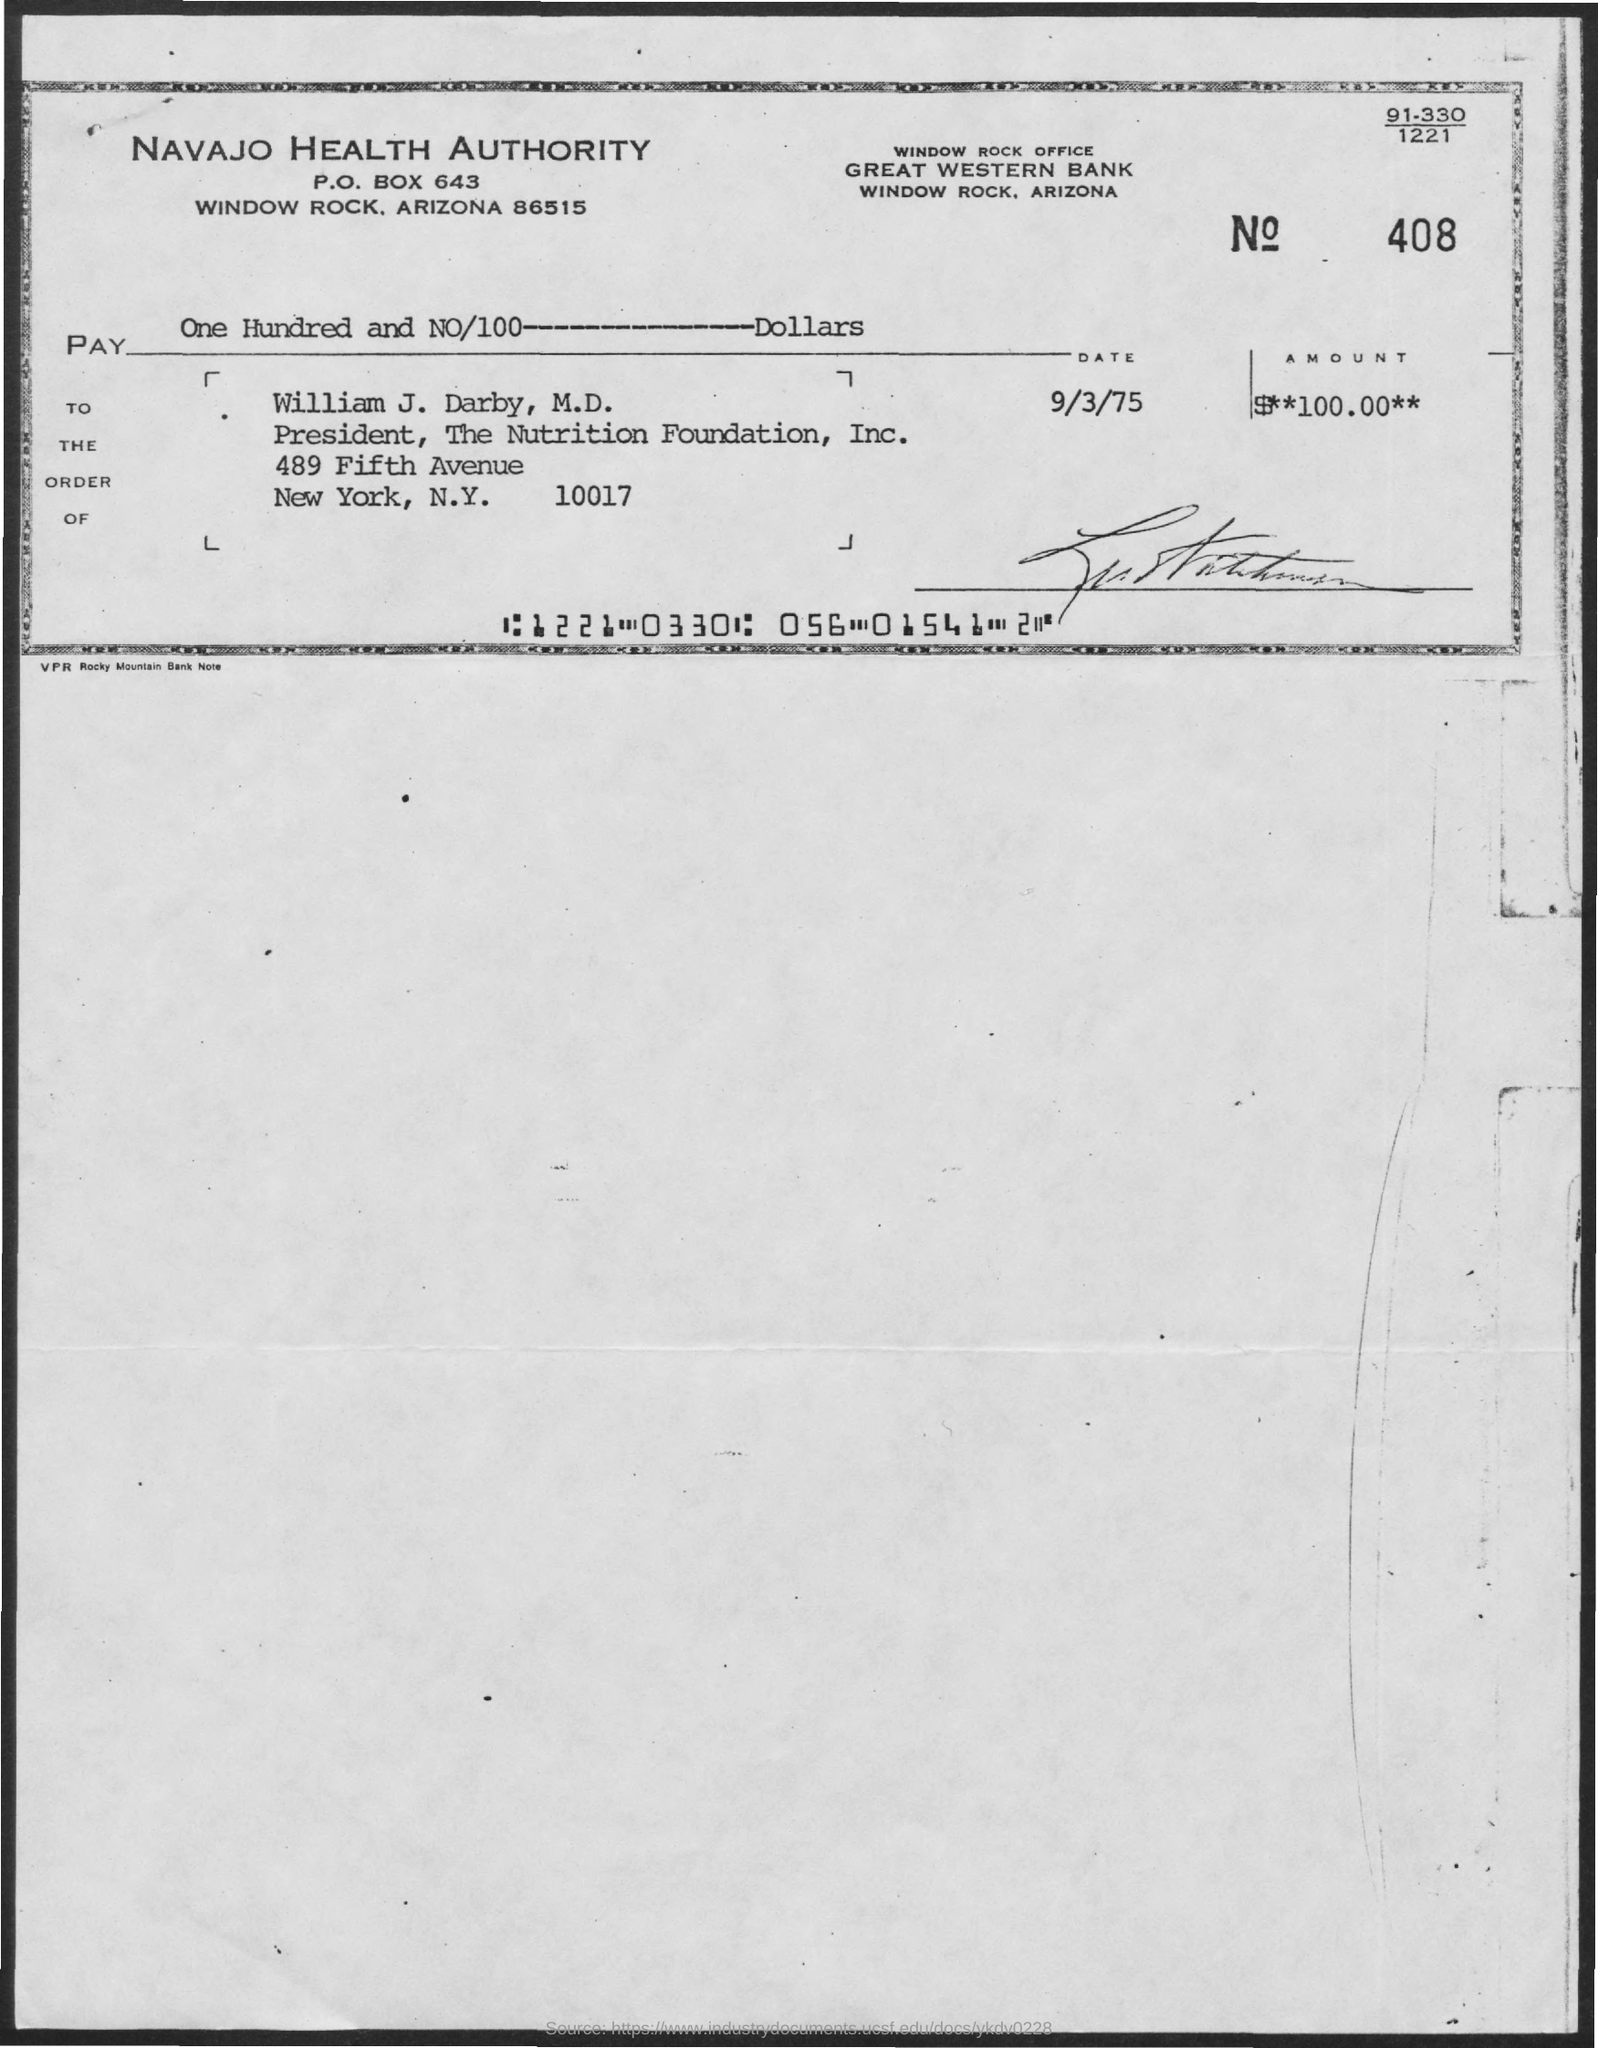Point out several critical features in this image. The check is issued in the name of William J. Darby, M.D. William J. Darby, M.D. holds the designation of President of The Nutrition Foundation, Inc. The check was issued by Great Western Bank. The date mentioned on the check is September 3, 1975. I have been given a check in the amount of $100.00. 